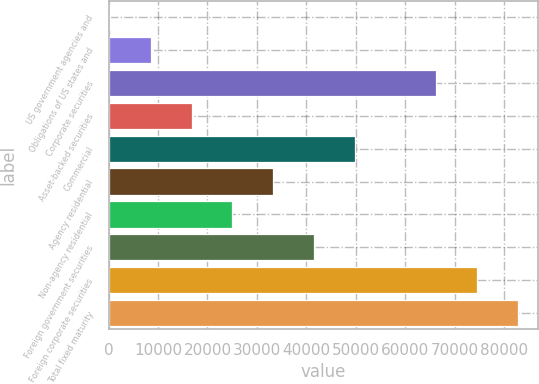Convert chart. <chart><loc_0><loc_0><loc_500><loc_500><bar_chart><fcel>US government agencies and<fcel>Obligations of US states and<fcel>Corporate securities<fcel>Asset-backed securities<fcel>Commercial<fcel>Agency residential<fcel>Non-agency residential<fcel>Foreign government securities<fcel>Foreign corporate securities<fcel>Total fixed maturity<nl><fcel>287<fcel>8532<fcel>66247<fcel>16777<fcel>49757<fcel>33267<fcel>25022<fcel>41512<fcel>74492<fcel>82737<nl></chart> 